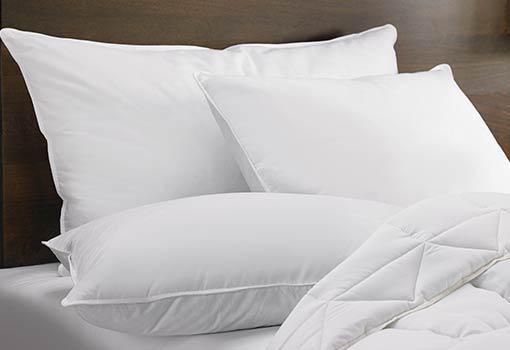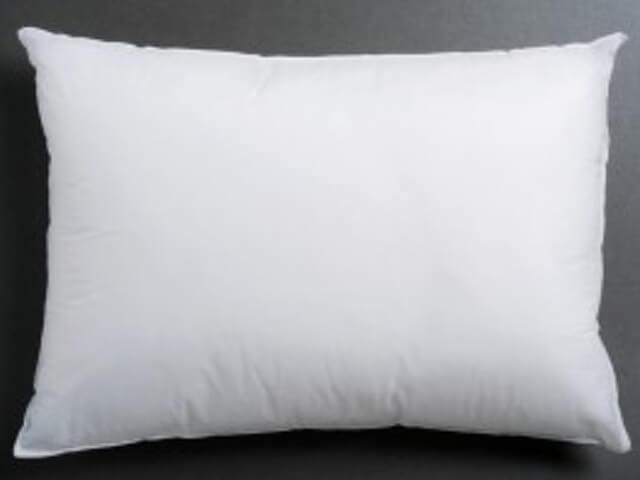The first image is the image on the left, the second image is the image on the right. Analyze the images presented: Is the assertion "An image contains exactly three white pillows, and an image shows multiple pillows on a bed with a white blanket." valid? Answer yes or no. Yes. The first image is the image on the left, the second image is the image on the right. For the images shown, is this caption "There are at most 3 pillows in the pair of images." true? Answer yes or no. No. 